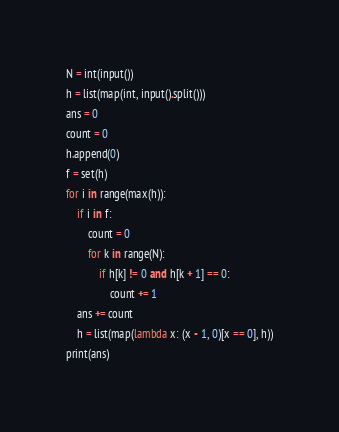<code> <loc_0><loc_0><loc_500><loc_500><_Python_>N = int(input())
h = list(map(int, input().split()))
ans = 0
count = 0
h.append(0)
f = set(h)
for i in range(max(h)):
    if i in f:
        count = 0
        for k in range(N):
            if h[k] != 0 and h[k + 1] == 0:
                count += 1
    ans += count
    h = list(map(lambda x: (x - 1, 0)[x == 0], h))
print(ans)</code> 